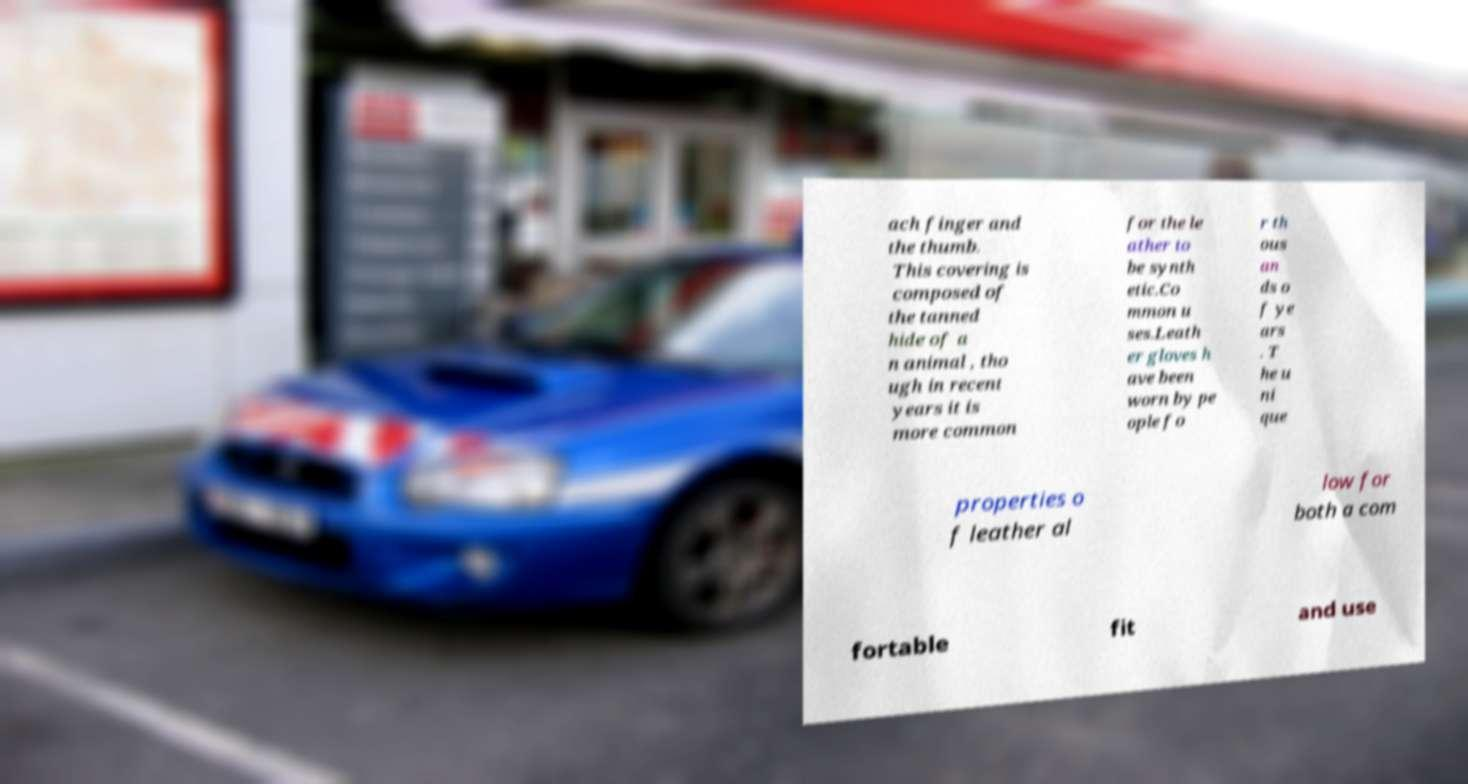I need the written content from this picture converted into text. Can you do that? ach finger and the thumb. This covering is composed of the tanned hide of a n animal , tho ugh in recent years it is more common for the le ather to be synth etic.Co mmon u ses.Leath er gloves h ave been worn by pe ople fo r th ous an ds o f ye ars . T he u ni que properties o f leather al low for both a com fortable fit and use 